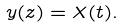<formula> <loc_0><loc_0><loc_500><loc_500>y ( z ) = X ( t ) .</formula> 